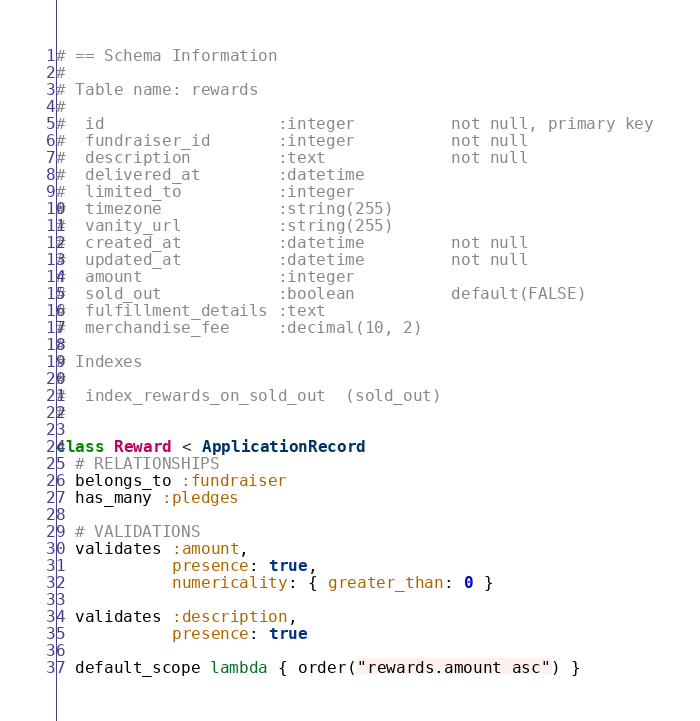Convert code to text. <code><loc_0><loc_0><loc_500><loc_500><_Ruby_># == Schema Information
#
# Table name: rewards
#
#  id                  :integer          not null, primary key
#  fundraiser_id       :integer          not null
#  description         :text             not null
#  delivered_at        :datetime
#  limited_to          :integer
#  timezone            :string(255)
#  vanity_url          :string(255)
#  created_at          :datetime         not null
#  updated_at          :datetime         not null
#  amount              :integer
#  sold_out            :boolean          default(FALSE)
#  fulfillment_details :text
#  merchandise_fee     :decimal(10, 2)
#
# Indexes
#
#  index_rewards_on_sold_out  (sold_out)
#

class Reward < ApplicationRecord
  # RELATIONSHIPS
  belongs_to :fundraiser
  has_many :pledges

  # VALIDATIONS
  validates :amount,
            presence: true,
            numericality: { greater_than: 0 }

  validates :description,
            presence: true

  default_scope lambda { order("rewards.amount asc") }</code> 